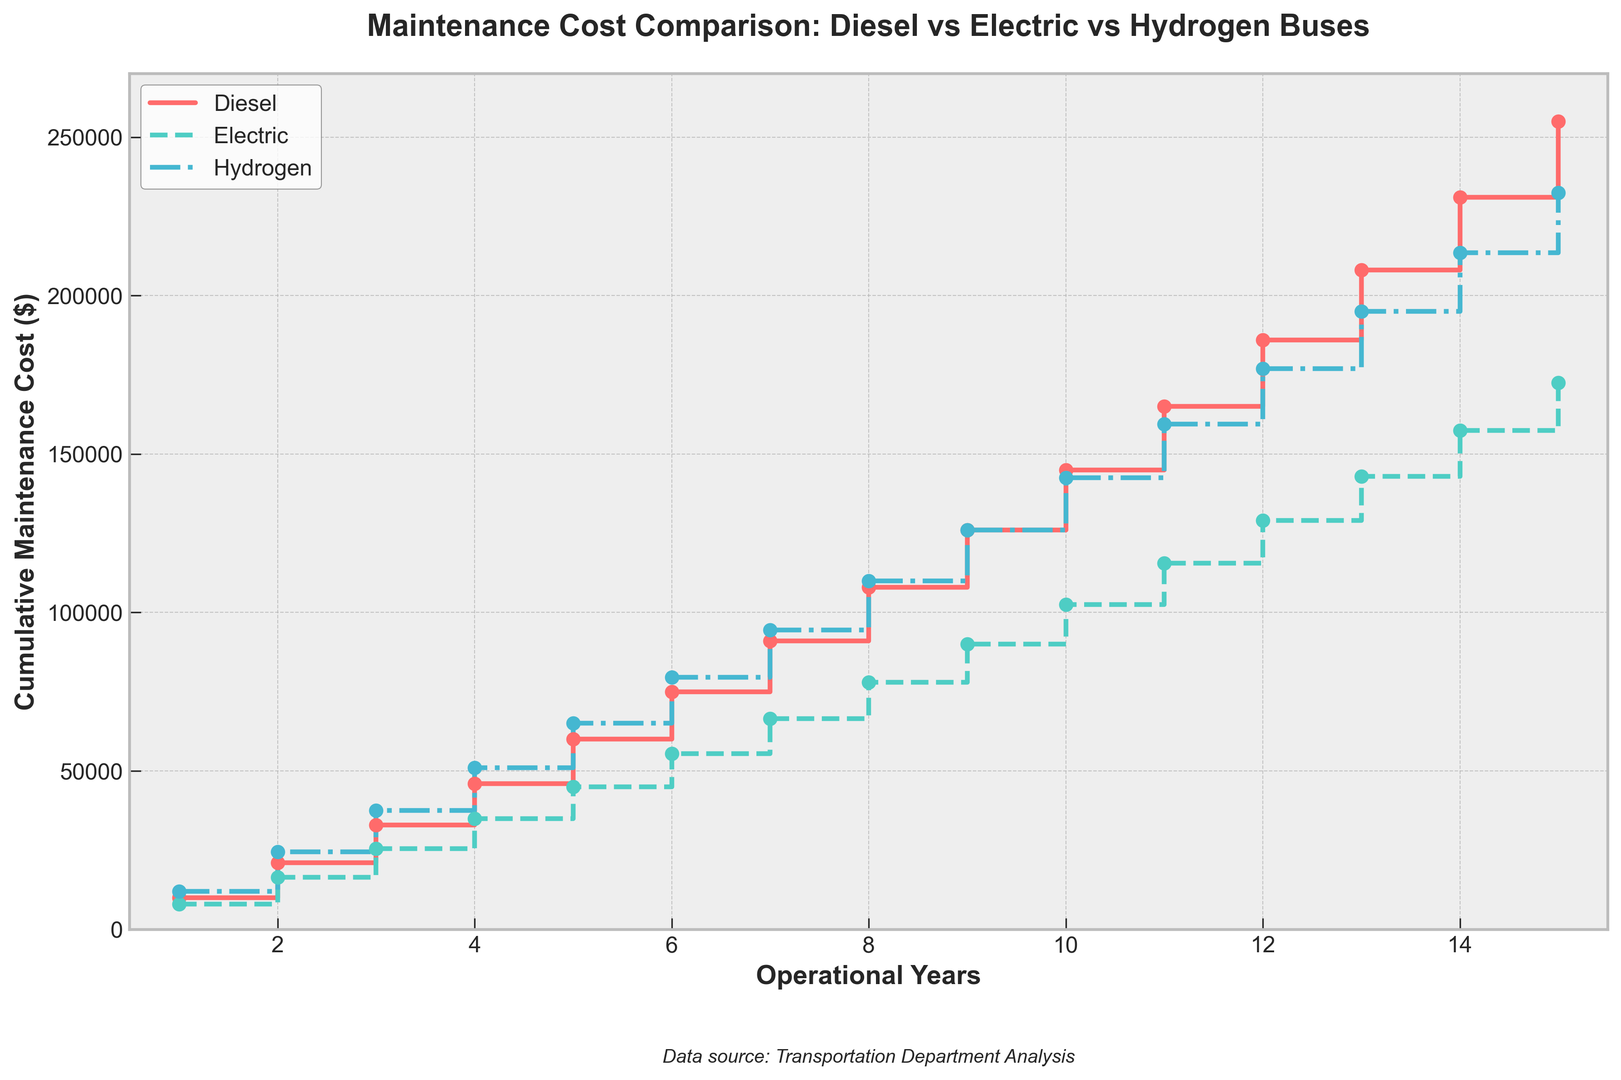Which type of bus has the highest cumulative maintenance cost after 10 years? By observing the heights of the steps at year 10, the Hydrogen bus has the highest cumulative maintenance cost amongst the Diesel, Electric, and Hydrogen options.
Answer: Hydrogen At year 5, what is the difference in maintenance cost between Electric and Diesel buses? At year 5, the cumulative maintenance cost for Electric buses is $45,000 and for Diesel buses is $60,000. The difference is $60,000 - $45,000 = $15,000.
Answer: $15,000 How does the maintenance cost of a Hydrogen bus compare to that of an Electric bus at the end of the operational lifespan (15 years)? At year 15, the maintenance cost for a Hydrogen bus is $232,500, while for an Electric bus it is $172,500. The Hydrogen bus has a higher maintenance cost by $232,500 - $172,500 = $60,000.
Answer: Hydrogen cost is higher by $60,000 What is the average maintenance cost of Electric buses at year 8? The cumulative maintenance cost for Electric buses at year 8 is $78,000. Since we want the average at this particular year, we don’t divide by the number of years.
Answer: $78,000 Which bus type exhibits the steepest increase in maintenance costs between years 5 and 6? Observe the rise between the steps from year 5 to year 6. The Diesel bus increases from $60,000 to $75,000 (+$15,000), Electric from $45,000 to $55,500 (+$10,500), and Hydrogen from $65,000 to $79,500 (+$14,500). Diesel has the steepest increase at $15,000.
Answer: Diesel From year 1 to year 15, which bus type accumulates the highest total maintenance cost? Observe each bus type at year 15: Diesel ($255,000), Electric ($172,500), and Hydrogen ($232,500). Diesel accumulates the highest total maintenance cost.
Answer: Diesel What is the combined maintenance cost of Diesel and Electric buses at year 12? At year 12, Diesel's cost is $186,000 and Electric's cost is $129,000. The combined cost is $186,000 + $129,000 = $315,000.
Answer: $315,000 From year 10 to year 15, which bus type sees the largest net increase in maintenance costs? For Diesel, the cost increases from $145,000 to $255,000 ($110,000 increase). For Electric, from $102,500 to $172,500 ($70,000 increase). For Hydrogen, from $142,500 to $232,500 ($90,000 increase). The Diesel bus sees the largest net increase of $110,000.
Answer: Diesel How does the maintenance cost trend of Electric buses compare relative to Diesel buses over time? Comparing trends, Diesel buses consistently exhibit a higher cumulative maintenance cost than Electric buses throughout their operational lifespan. The gap between their costs also widens over time.
Answer: Diesel buses cost more consistently and increasingly over time 